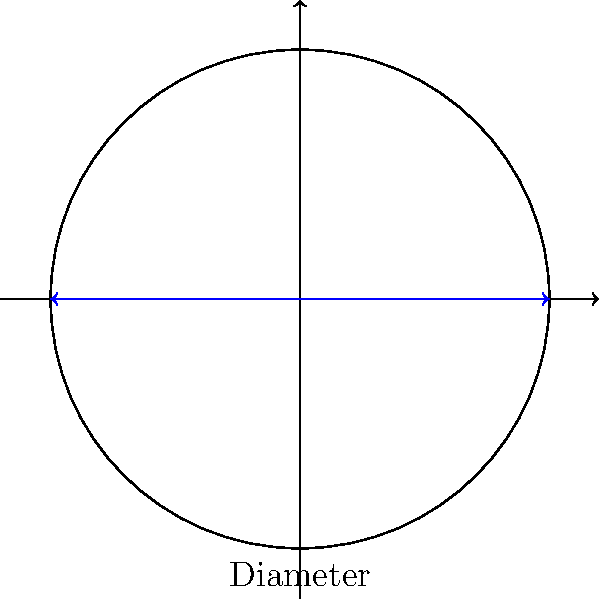As part of a Mars exploration mission, you need to calculate the area of a circular landing pad. The landing pad has a diameter of 30 meters. What is the area of the landing pad in square meters? Round your answer to the nearest whole number. To calculate the area of a circular landing pad, we need to follow these steps:

1. Recall the formula for the area of a circle: $A = \pi r^2$, where $A$ is the area and $r$ is the radius.

2. We are given the diameter, which is 30 meters. The radius is half of the diameter:
   $r = \frac{diameter}{2} = \frac{30}{2} = 15$ meters

3. Now, let's substitute the radius into the area formula:
   $A = \pi r^2 = \pi (15)^2 = \pi (225)$

4. Calculate the result:
   $A = \pi (225) \approx 706.86$ square meters

5. Rounding to the nearest whole number:
   $A \approx 707$ square meters
Answer: 707 square meters 